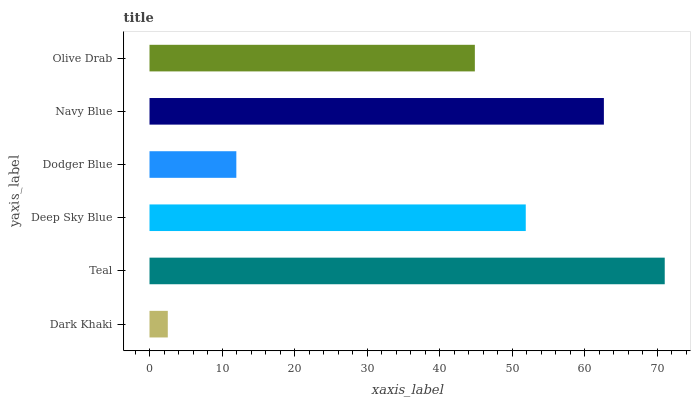Is Dark Khaki the minimum?
Answer yes or no. Yes. Is Teal the maximum?
Answer yes or no. Yes. Is Deep Sky Blue the minimum?
Answer yes or no. No. Is Deep Sky Blue the maximum?
Answer yes or no. No. Is Teal greater than Deep Sky Blue?
Answer yes or no. Yes. Is Deep Sky Blue less than Teal?
Answer yes or no. Yes. Is Deep Sky Blue greater than Teal?
Answer yes or no. No. Is Teal less than Deep Sky Blue?
Answer yes or no. No. Is Deep Sky Blue the high median?
Answer yes or no. Yes. Is Olive Drab the low median?
Answer yes or no. Yes. Is Teal the high median?
Answer yes or no. No. Is Dodger Blue the low median?
Answer yes or no. No. 